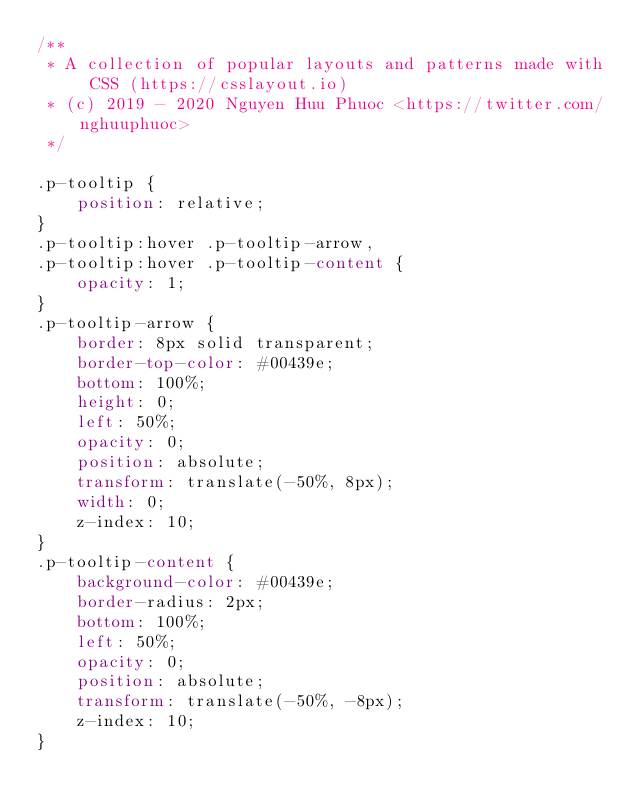Convert code to text. <code><loc_0><loc_0><loc_500><loc_500><_CSS_>/**
 * A collection of popular layouts and patterns made with CSS (https://csslayout.io)
 * (c) 2019 - 2020 Nguyen Huu Phuoc <https://twitter.com/nghuuphuoc>
 */

.p-tooltip {
    position: relative;
}
.p-tooltip:hover .p-tooltip-arrow,
.p-tooltip:hover .p-tooltip-content {
    opacity: 1;
}
.p-tooltip-arrow {
    border: 8px solid transparent;
    border-top-color: #00439e;
    bottom: 100%;
    height: 0;
    left: 50%;
    opacity: 0;
    position: absolute;
    transform: translate(-50%, 8px);
    width: 0;
    z-index: 10;
}
.p-tooltip-content {
    background-color: #00439e;
    border-radius: 2px;
    bottom: 100%;
    left: 50%;
    opacity: 0;
    position: absolute;
    transform: translate(-50%, -8px);
    z-index: 10;
}
</code> 